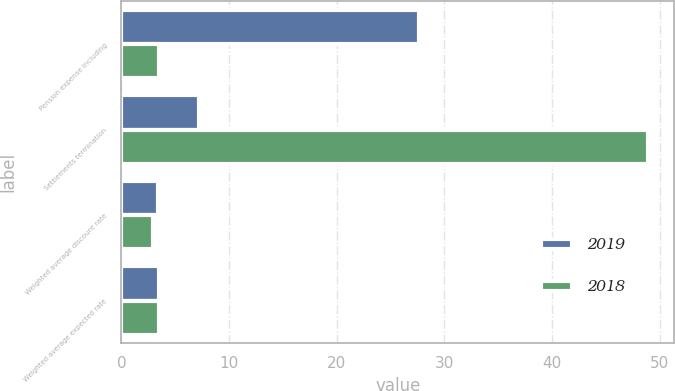Convert chart. <chart><loc_0><loc_0><loc_500><loc_500><stacked_bar_chart><ecel><fcel>Pension expense including<fcel>Settlements termination<fcel>Weighted average discount rate<fcel>Weighted average expected rate<nl><fcel>2019<fcel>27.6<fcel>7.2<fcel>3.4<fcel>3.5<nl><fcel>2018<fcel>3.5<fcel>48.9<fcel>2.9<fcel>3.5<nl></chart> 